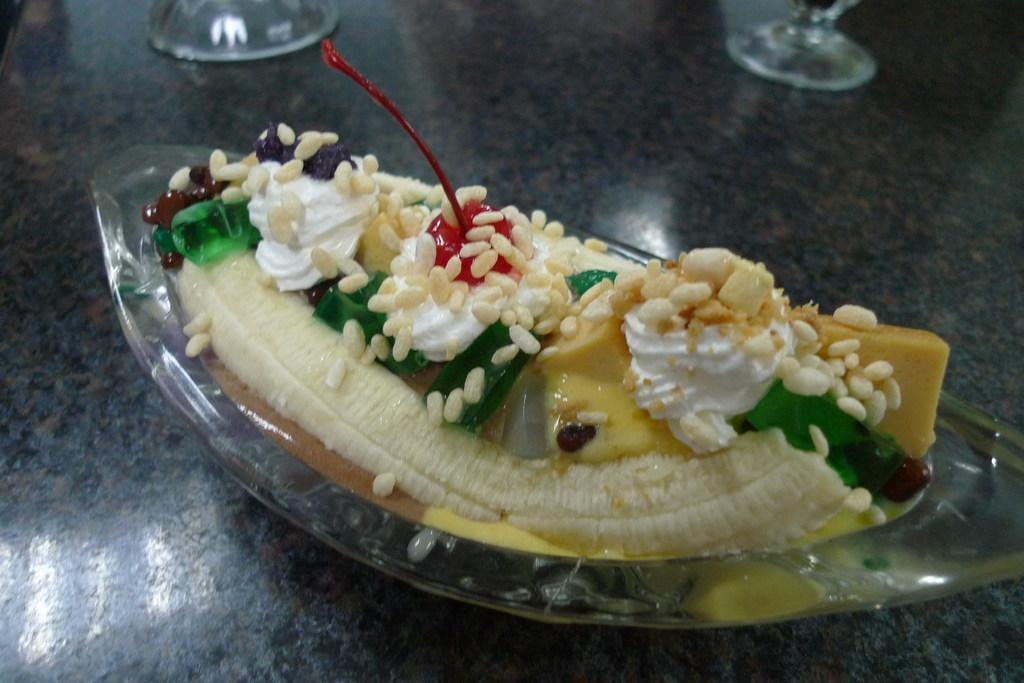What is in the bowl that is visible in the image? There is a bowl with food items in the image. What is the surface on which the bowl is placed? The bowl is on a black marble surface. Are there any other items visible near the bowl? There may be glasses present beside the bowl. What type of cord is connected to the food items in the image? There is no cord connected to the food items in the image; it is a bowl of food on a surface. 